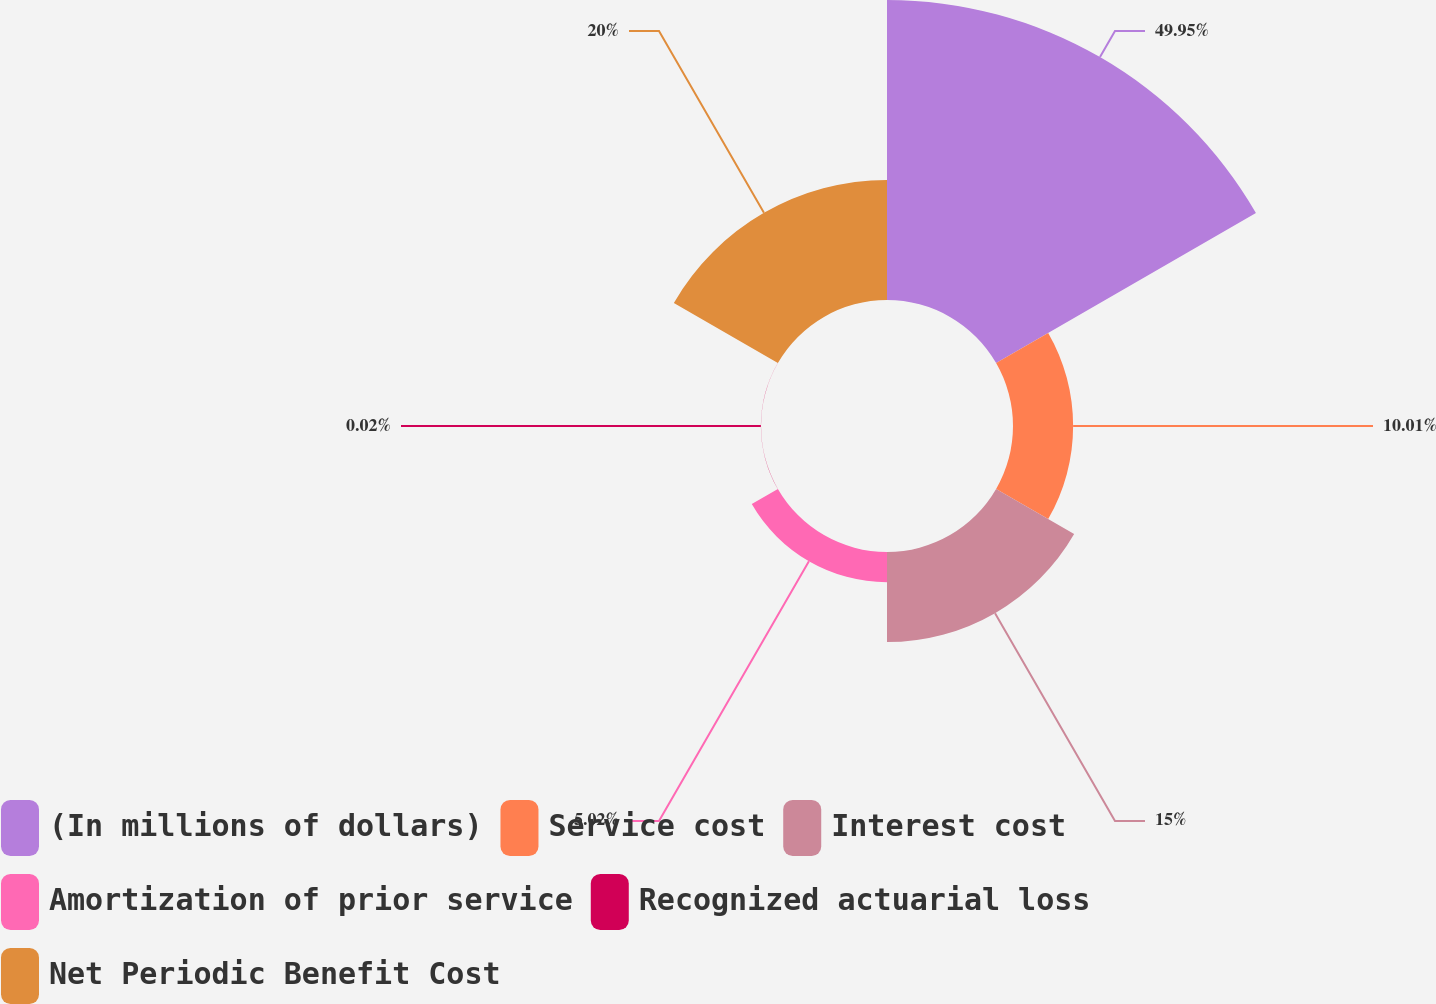Convert chart to OTSL. <chart><loc_0><loc_0><loc_500><loc_500><pie_chart><fcel>(In millions of dollars)<fcel>Service cost<fcel>Interest cost<fcel>Amortization of prior service<fcel>Recognized actuarial loss<fcel>Net Periodic Benefit Cost<nl><fcel>49.95%<fcel>10.01%<fcel>15.0%<fcel>5.02%<fcel>0.02%<fcel>20.0%<nl></chart> 